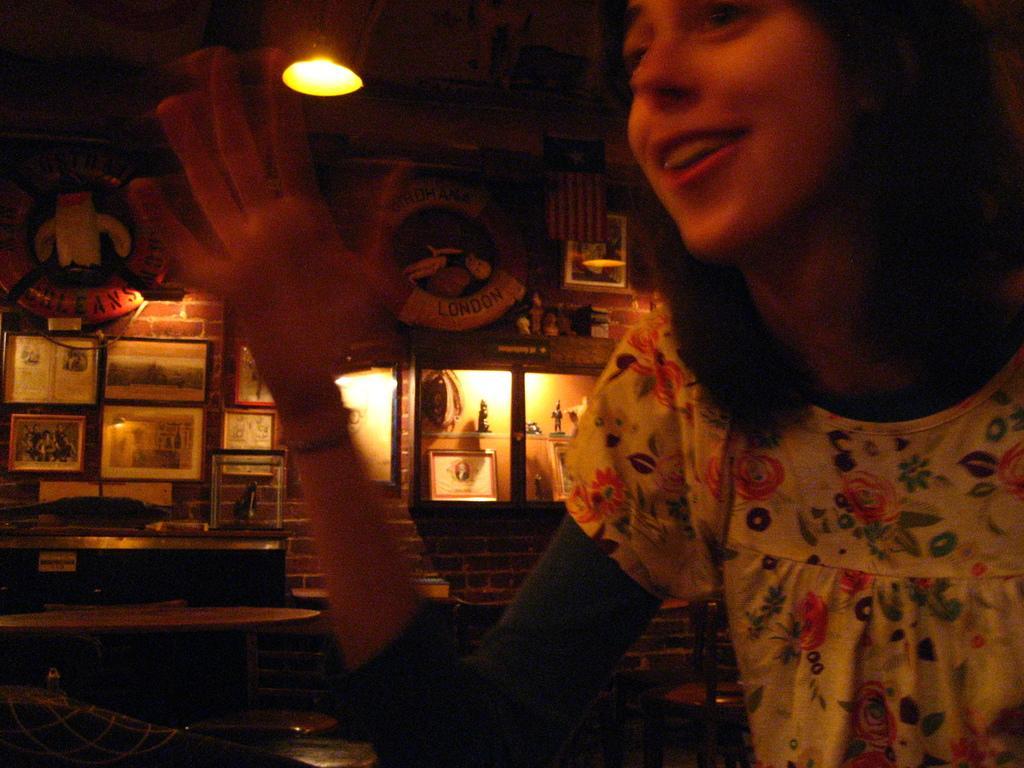How would you summarize this image in a sentence or two? In this image I can see a person wearing white color shirt, background I can see few frames attached to the wall and I can see a light. 